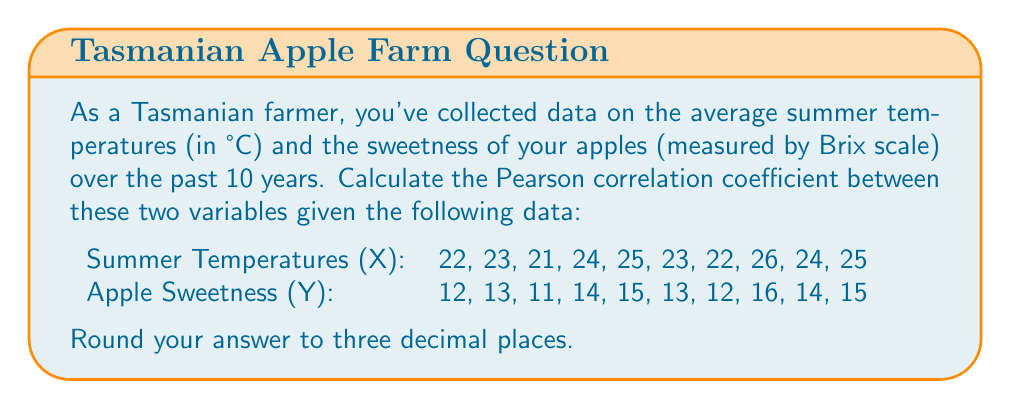Can you answer this question? To calculate the Pearson correlation coefficient (r) between summer temperatures (X) and apple sweetness (Y), we'll use the formula:

$$ r = \frac{\sum_{i=1}^{n} (x_i - \bar{x})(y_i - \bar{y})}{\sqrt{\sum_{i=1}^{n} (x_i - \bar{x})^2 \sum_{i=1}^{n} (y_i - \bar{y})^2}} $$

Where $\bar{x}$ and $\bar{y}$ are the means of X and Y respectively.

Step 1: Calculate the means
$\bar{x} = \frac{22 + 23 + 21 + 24 + 25 + 23 + 22 + 26 + 24 + 25}{10} = 23.5$
$\bar{y} = \frac{12 + 13 + 11 + 14 + 15 + 13 + 12 + 16 + 14 + 15}{10} = 13.5$

Step 2: Calculate $(x_i - \bar{x})$, $(y_i - \bar{y})$, $(x_i - \bar{x})^2$, $(y_i - \bar{y})^2$, and $(x_i - \bar{x})(y_i - \bar{y})$ for each pair of values.

Step 3: Sum up the calculated values:
$\sum (x_i - \bar{x})(y_i - \bar{y}) = 30$
$\sum (x_i - \bar{x})^2 = 30$
$\sum (y_i - \bar{y})^2 = 30$

Step 4: Apply the formula:

$$ r = \frac{30}{\sqrt{30 \times 30}} = \frac{30}{30} = 1 $$

Therefore, the Pearson correlation coefficient is 1.000 (rounded to three decimal places).
Answer: 1.000 